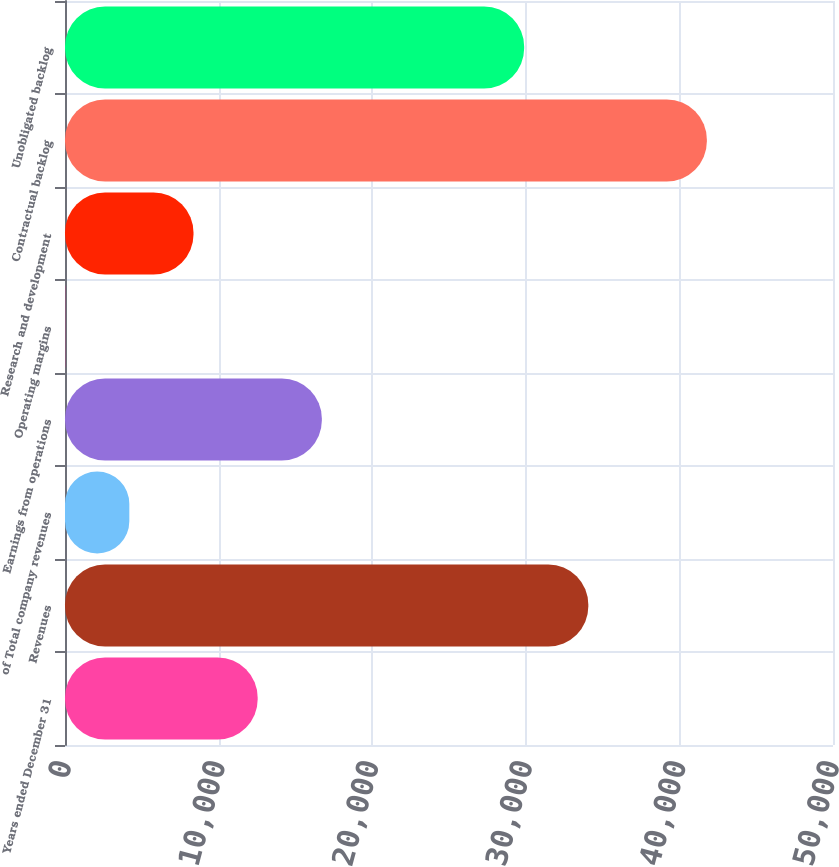Convert chart. <chart><loc_0><loc_0><loc_500><loc_500><bar_chart><fcel>Years ended December 31<fcel>Revenues<fcel>of Total company revenues<fcel>Earnings from operations<fcel>Operating margins<fcel>Research and development<fcel>Contractual backlog<fcel>Unobligated backlog<nl><fcel>12543.9<fcel>34070.7<fcel>4188.43<fcel>16721.6<fcel>10.7<fcel>8366.16<fcel>41788<fcel>29893<nl></chart> 